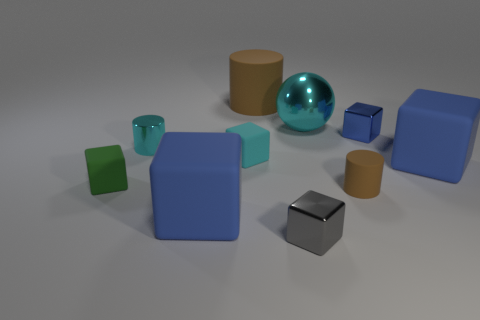There is a metal thing that is the same color as the sphere; what shape is it?
Offer a very short reply. Cylinder. How many cyan matte things are the same size as the blue metallic thing?
Your answer should be very brief. 1. Does the small metal thing on the left side of the cyan cube have the same shape as the blue matte object that is on the right side of the large brown cylinder?
Your answer should be very brief. No. The small cylinder that is on the left side of the cyan shiny thing on the right side of the blue block that is in front of the tiny brown cylinder is made of what material?
Ensure brevity in your answer.  Metal. What is the shape of the brown object that is the same size as the green matte object?
Provide a succinct answer. Cylinder. Are there any matte blocks of the same color as the ball?
Give a very brief answer. Yes. The cyan shiny sphere has what size?
Provide a short and direct response. Large. Does the small gray thing have the same material as the large ball?
Give a very brief answer. Yes. There is a brown matte cylinder to the right of the gray thing that is in front of the big cyan ball; how many large blue matte cubes are in front of it?
Your answer should be very brief. 1. What is the shape of the big brown matte thing behind the green matte object?
Offer a terse response. Cylinder. 